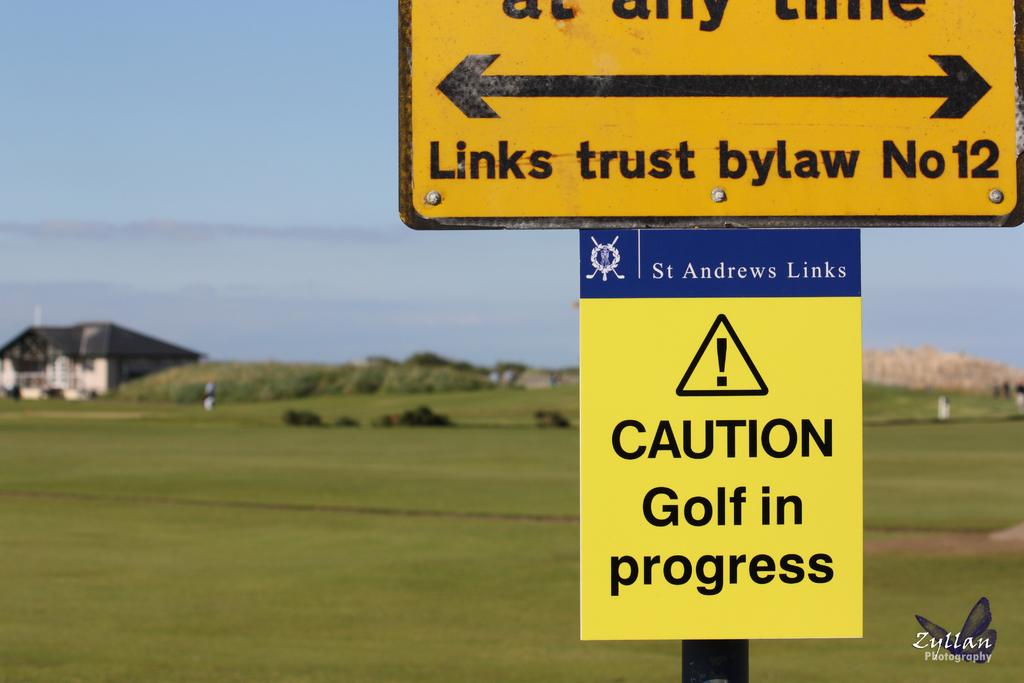What is attached to the pole in the image? There are boards on a pole in the image. What type of natural environment is visible in the image? There is grass visible in the image, and trees are in the background. What type of structure can be seen in the background of the image? There is a house in the background of the image. What is visible in the sky in the image? The sky is visible in the background of the image. What is located in the bottom right of the image? There is a logo and text in the bottom right of the image. How many chickens are pecking at the hole in the boards in the image? There are no chickens or holes present in the image; it features boards on a pole with no visible damage or animals. 